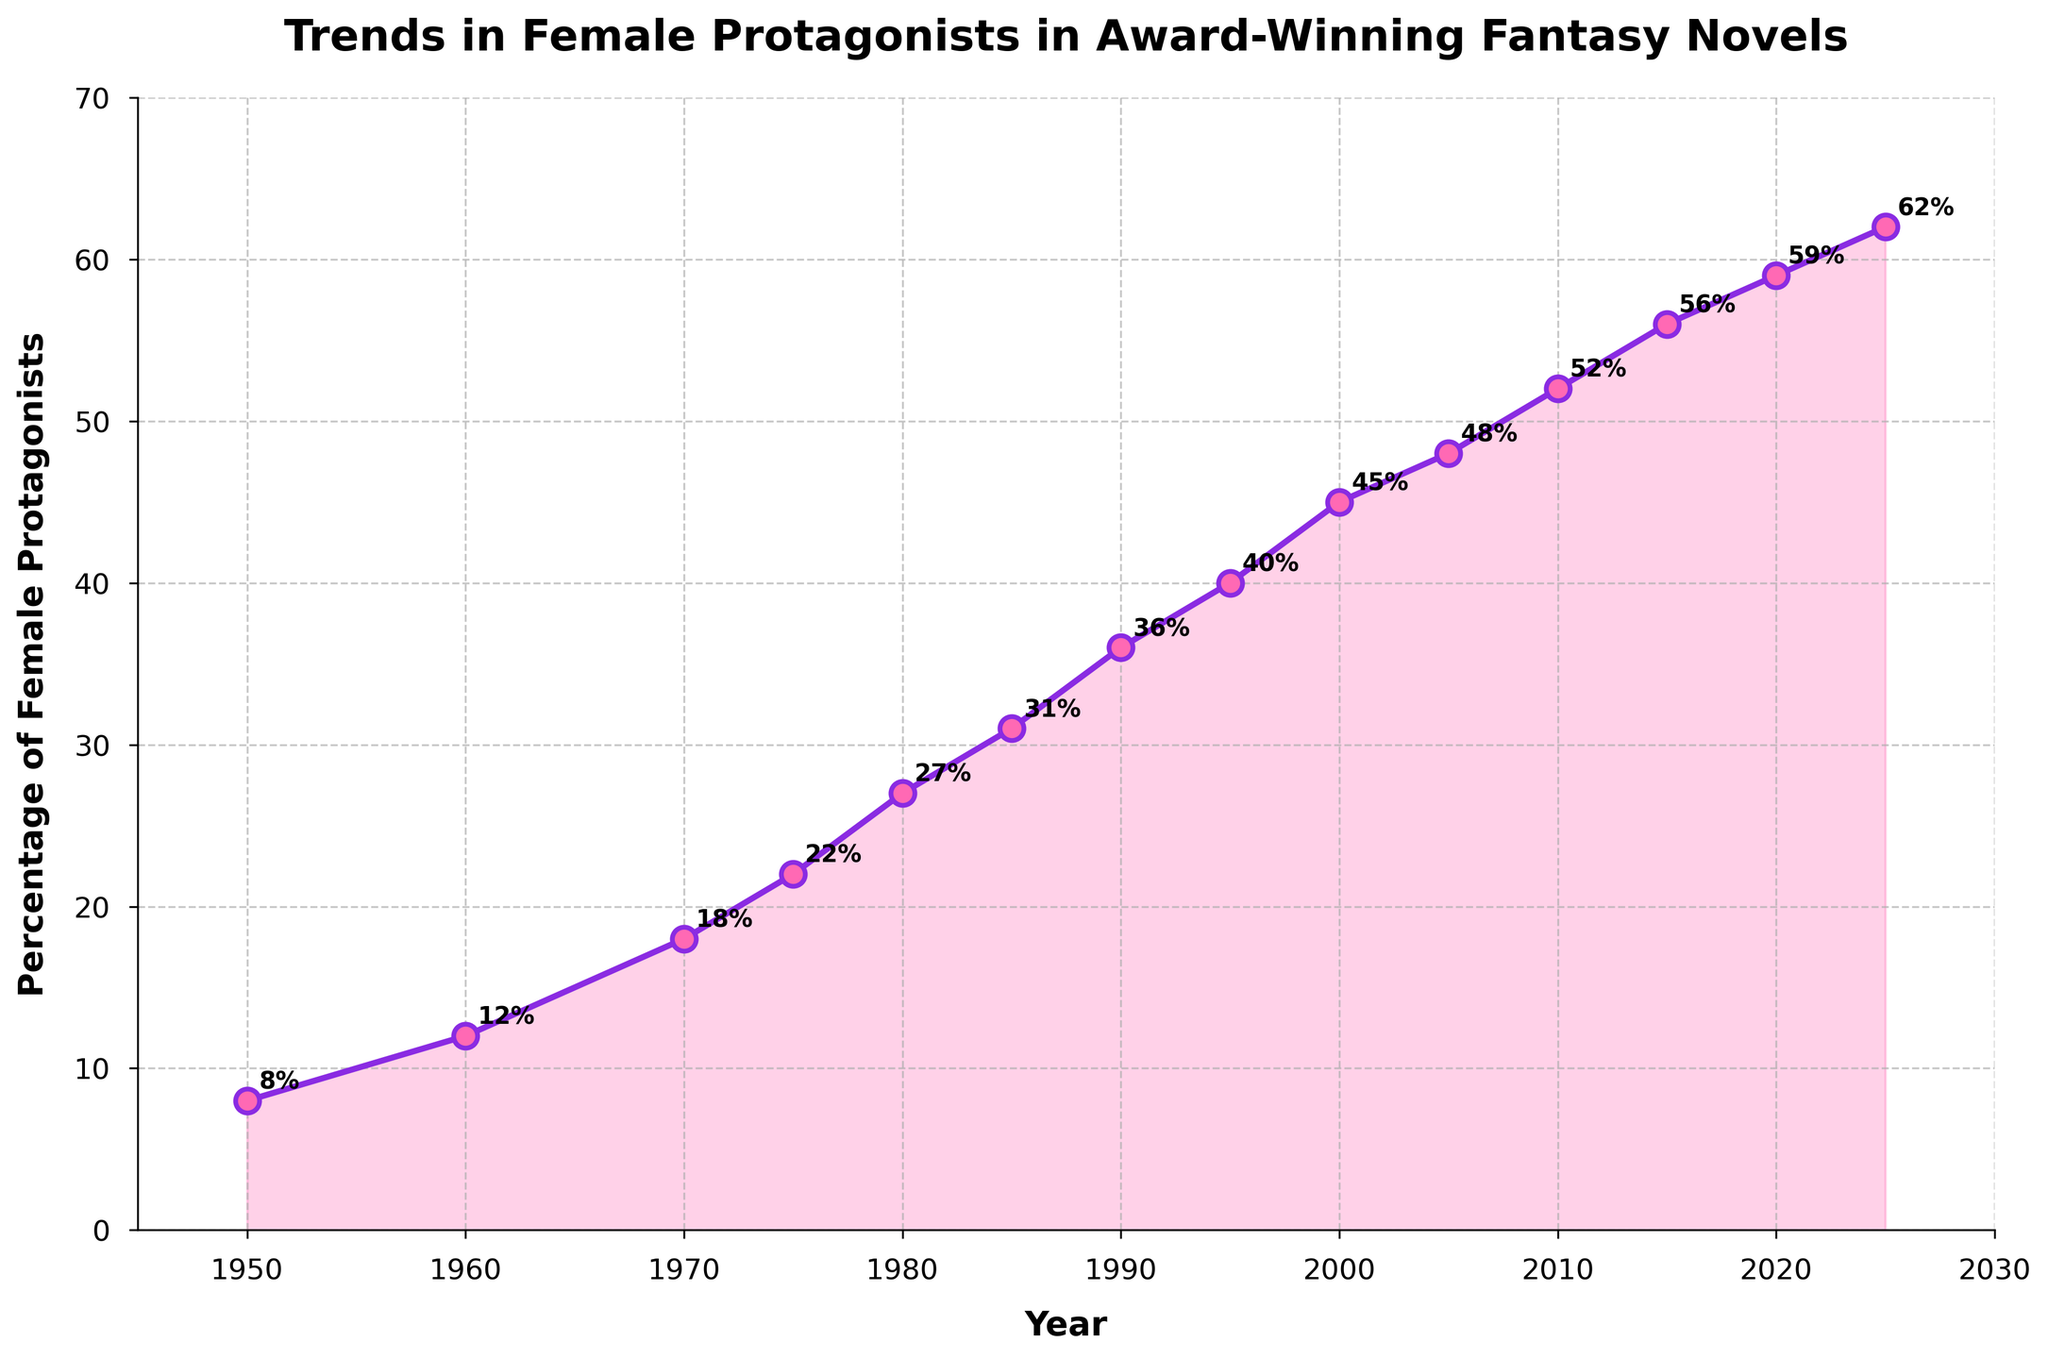What year had the highest percentage of female protagonists in award-winning fantasy novels? The highest point on the line chart corresponds to the year 2025 with a percentage of 62%.
Answer: 2025 By how much did the percentage of female protagonists increase between 1950 and 2000? Subtract the percentage in 1950 (8%) from the percentage in 2000 (45%). The increase is 45% - 8% = 37%.
Answer: 37% Is the trend of female protagonists in award-winning fantasy novels increasing or decreasing? The line chart shows a consistent upward trend from 1950 to 2025, indicating an increase.
Answer: Increasing Compare the percentage of female protagonists in 1980 and 2010. Which year had a higher percentage and by how much? In 1980, the percentage was 27%, and in 2010, it was 52%. The difference is 52% - 27% = 25%. 2010 had a higher percentage by 25%.
Answer: 2010 by 25% What is the approximate average percentage of female protagonists from 1950 to 2025? Sum the percentages for all the years and then divide by the number of years. (8 + 12 + 18 + 22 + 27 + 31 + 36 + 40 + 45 + 48 + 52 + 56 + 59 + 62) / 14 ≈ 37.4%
Answer: 37.4% Between which consecutive decades did the percentage of female protagonists increase the most? Calculate the differences between consecutive decades: 
1950 to 1960: 12 - 8 = 4
1960 to 1970: 18 - 12 = 6
1970 to 1980: 27 - 18 = 9
1980 to 1990: 36 - 27 = 9
1990 to 2000: 45 - 36 = 9
2000 to 2010: 52 - 45 = 7
2010 to 2020: 59 - 52 = 7
2020 to 2025: 62 - 59 = 3
 The greatest increase is 9% across three intervals: 1970-1980, 1980-1990, and 1990-2000.
Answer: 1970-1980, 1980-1990, and 1990-2000 How many times does the line cross the 50% mark? The line crosses the 50% mark once, between the years 2005 and 2010.
Answer: Once What visual elements are used to highlight the trend in the percentage of female protagonists? The line is plotted in purple with a pink fill underneath it, and the markers are pink with purple outlines. Annotations for each value are also provided.
Answer: Line, fill, and annotations 